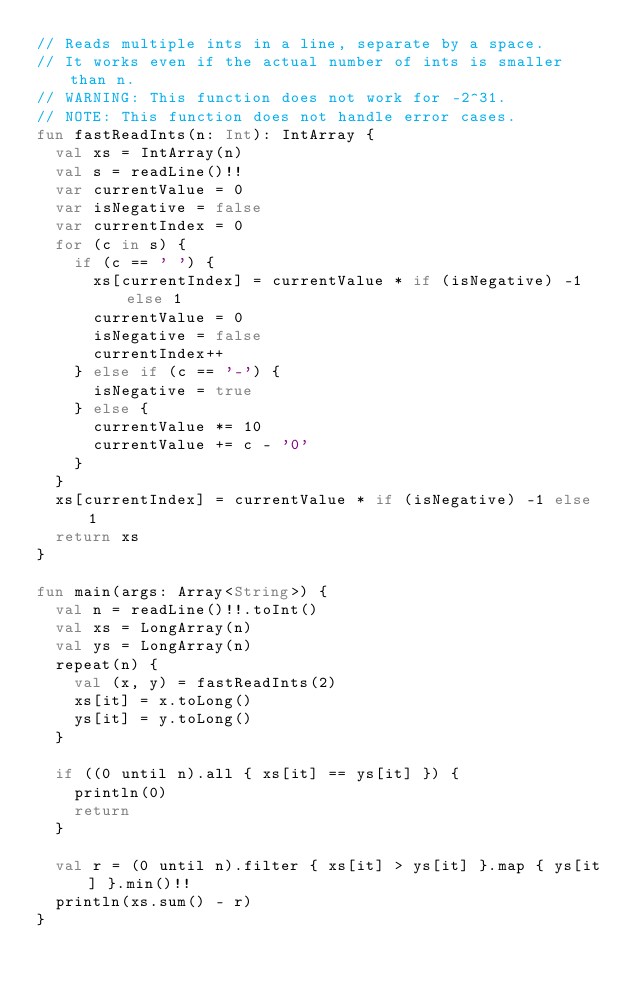<code> <loc_0><loc_0><loc_500><loc_500><_Kotlin_>// Reads multiple ints in a line, separate by a space.
// It works even if the actual number of ints is smaller than n.
// WARNING: This function does not work for -2^31.
// NOTE: This function does not handle error cases.
fun fastReadInts(n: Int): IntArray {
  val xs = IntArray(n)
  val s = readLine()!!
  var currentValue = 0
  var isNegative = false
  var currentIndex = 0
  for (c in s) {
    if (c == ' ') {
      xs[currentIndex] = currentValue * if (isNegative) -1 else 1
      currentValue = 0
      isNegative = false
      currentIndex++
    } else if (c == '-') {
      isNegative = true
    } else {
      currentValue *= 10
      currentValue += c - '0'
    }
  }
  xs[currentIndex] = currentValue * if (isNegative) -1 else 1
  return xs
}

fun main(args: Array<String>) {
  val n = readLine()!!.toInt()
  val xs = LongArray(n)
  val ys = LongArray(n)
  repeat(n) {
    val (x, y) = fastReadInts(2)
    xs[it] = x.toLong()
    ys[it] = y.toLong()
  }

  if ((0 until n).all { xs[it] == ys[it] }) {
    println(0)
    return
  }

  val r = (0 until n).filter { xs[it] > ys[it] }.map { ys[it] }.min()!!
  println(xs.sum() - r)
}</code> 